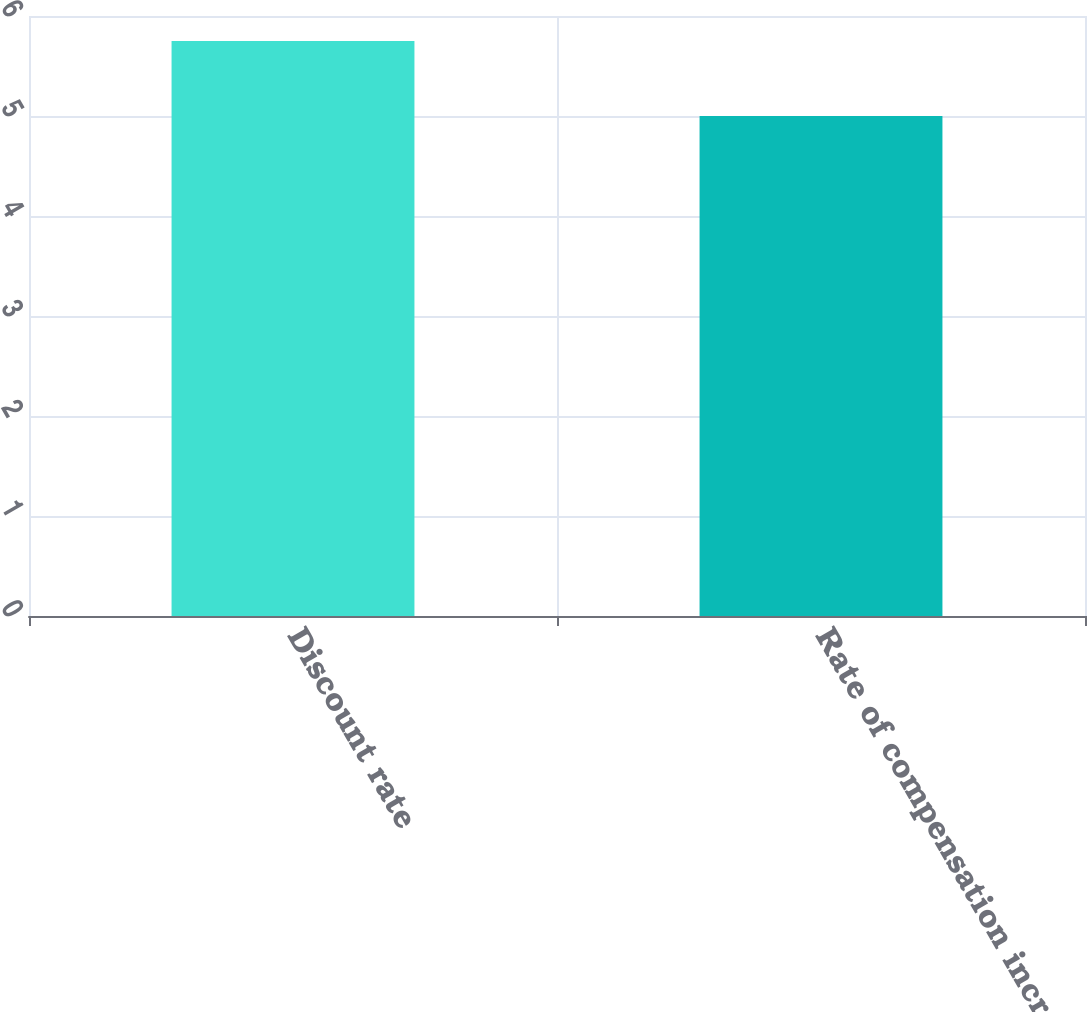Convert chart. <chart><loc_0><loc_0><loc_500><loc_500><bar_chart><fcel>Discount rate<fcel>Rate of compensation increase<nl><fcel>5.75<fcel>5<nl></chart> 